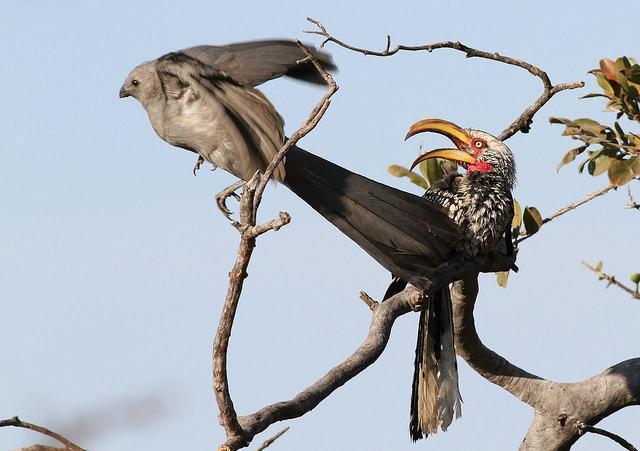How many birds?
Give a very brief answer. 2. 